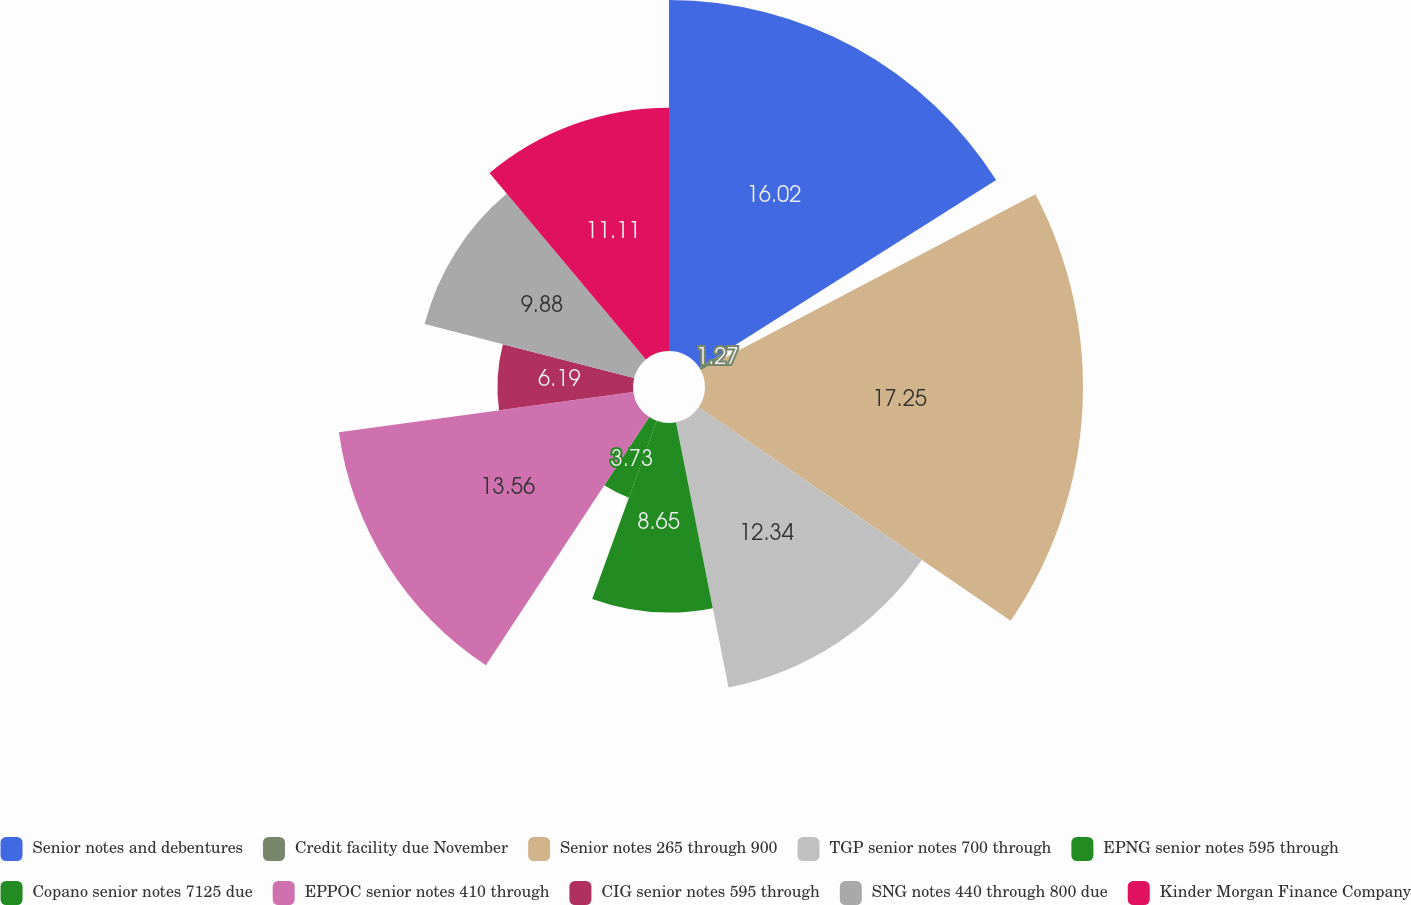Convert chart. <chart><loc_0><loc_0><loc_500><loc_500><pie_chart><fcel>Senior notes and debentures<fcel>Credit facility due November<fcel>Senior notes 265 through 900<fcel>TGP senior notes 700 through<fcel>EPNG senior notes 595 through<fcel>Copano senior notes 7125 due<fcel>EPPOC senior notes 410 through<fcel>CIG senior notes 595 through<fcel>SNG notes 440 through 800 due<fcel>Kinder Morgan Finance Company<nl><fcel>16.03%<fcel>1.27%<fcel>17.26%<fcel>12.34%<fcel>8.65%<fcel>3.73%<fcel>13.57%<fcel>6.19%<fcel>9.88%<fcel>11.11%<nl></chart> 